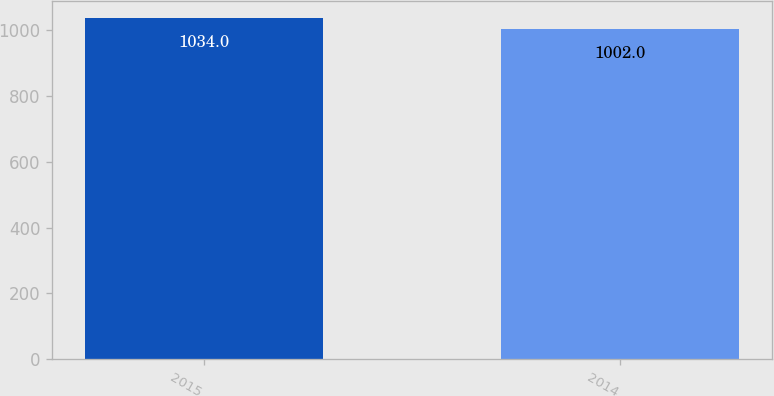Convert chart. <chart><loc_0><loc_0><loc_500><loc_500><bar_chart><fcel>2015<fcel>2014<nl><fcel>1034<fcel>1002<nl></chart> 